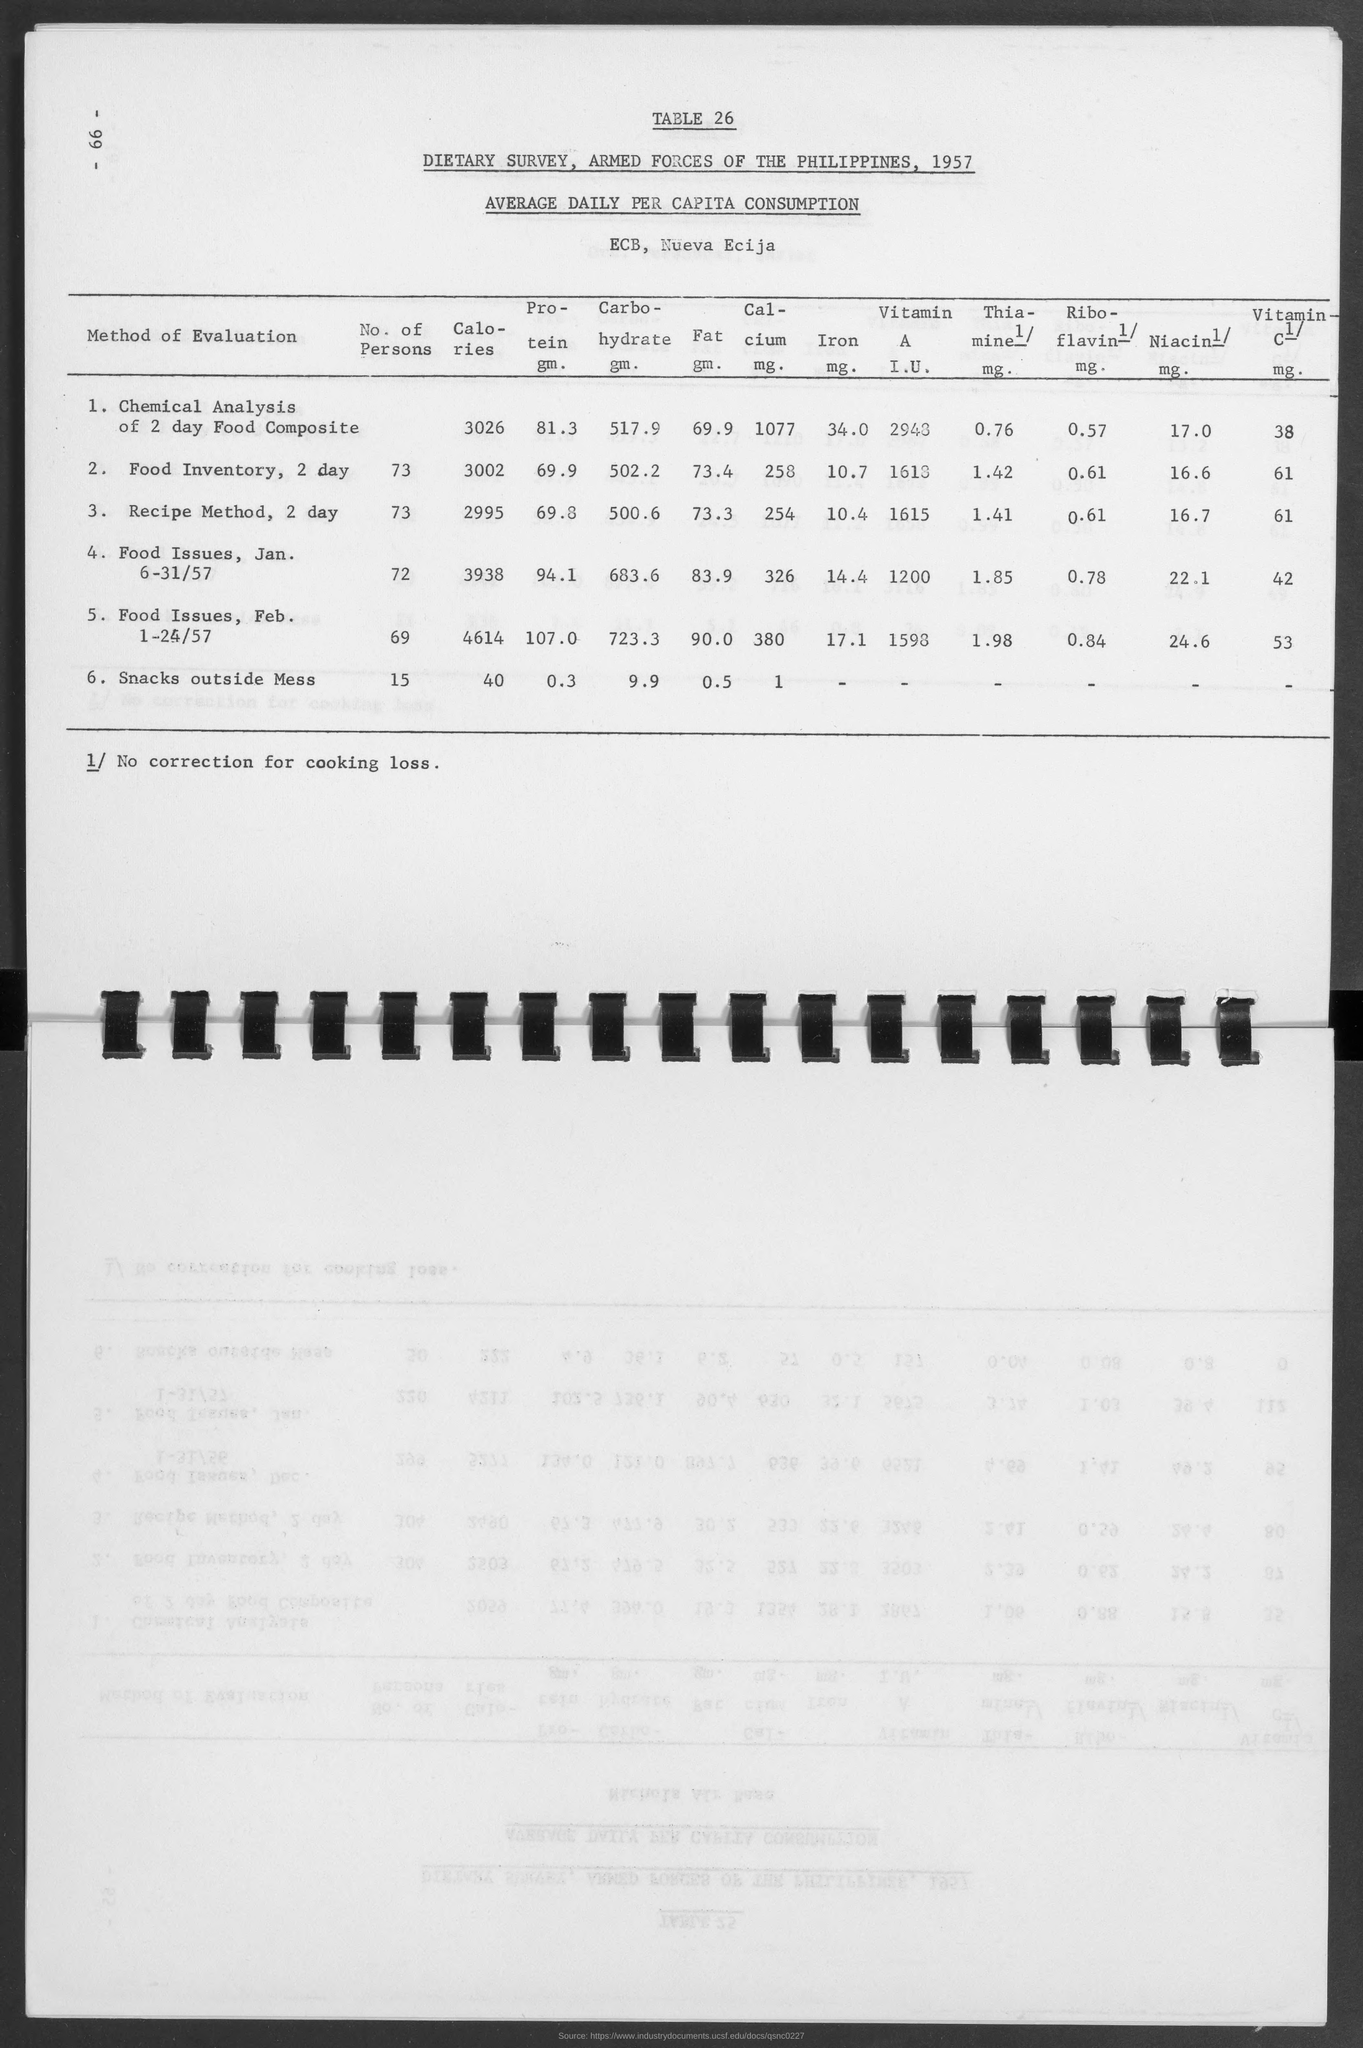Point out several critical features in this image. The chemical analysis of a 2-day food composite revealed the presence of 3026 calories. Food issues for the month of February 1-24/57 contained 4614 calories. The amount of protein in the food inventory for the next two days is 69.9 grams. What is the table number?" the woman asked, pointing to a table numbered 26. The amount of calories for food issues during the month of January 1957 was 3,938. 